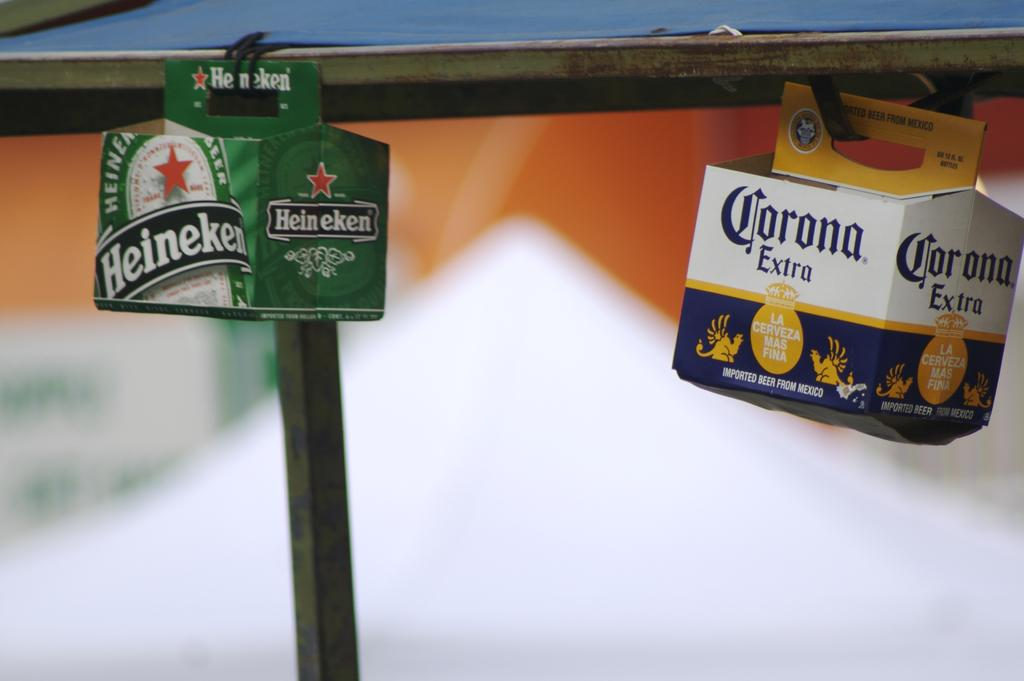How many boxes are present in the image? There are two boxes in the image. What is the surface that the boxes are attached to? The boxes are attached to an iron surface. What can be seen in the background of the image? There is a pole in the background of the image. What colors are the boxes? The boxes are green and white in color. What type of tub is visible in the image? There is no tub present in the image. How does the laborer interact with the boxes in the image? There is no laborer present in the image; it only shows the boxes and the iron surface. 